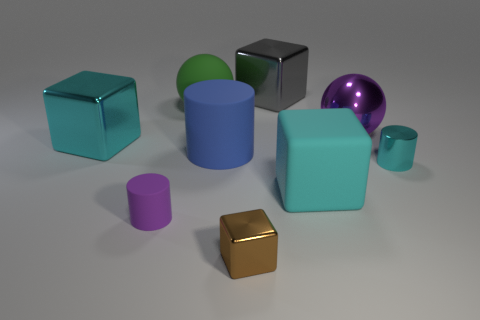How many cyan cubes must be subtracted to get 1 cyan cubes? 1 Add 1 large blue rubber objects. How many objects exist? 10 Subtract all purple cylinders. How many cylinders are left? 2 Subtract all cylinders. How many objects are left? 6 Subtract 1 cylinders. How many cylinders are left? 2 Subtract all blue cylinders. How many gray blocks are left? 1 Subtract all gray rubber blocks. Subtract all green rubber spheres. How many objects are left? 8 Add 1 big green spheres. How many big green spheres are left? 2 Add 5 large cyan rubber blocks. How many large cyan rubber blocks exist? 6 Subtract all cyan cylinders. How many cylinders are left? 2 